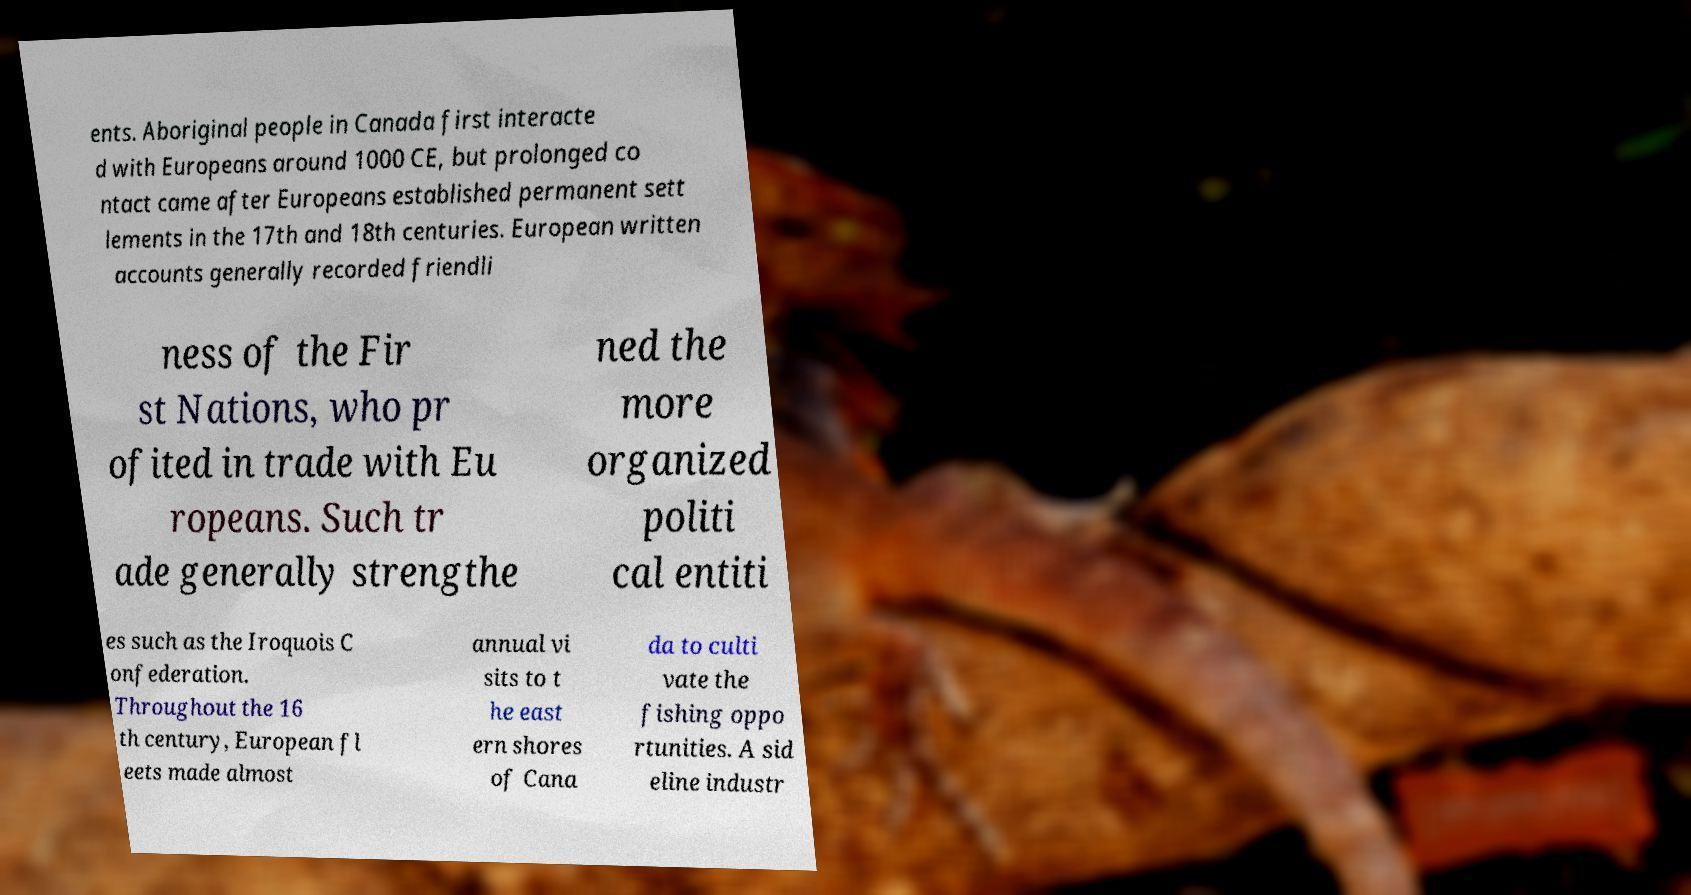For documentation purposes, I need the text within this image transcribed. Could you provide that? ents. Aboriginal people in Canada first interacte d with Europeans around 1000 CE, but prolonged co ntact came after Europeans established permanent sett lements in the 17th and 18th centuries. European written accounts generally recorded friendli ness of the Fir st Nations, who pr ofited in trade with Eu ropeans. Such tr ade generally strengthe ned the more organized politi cal entiti es such as the Iroquois C onfederation. Throughout the 16 th century, European fl eets made almost annual vi sits to t he east ern shores of Cana da to culti vate the fishing oppo rtunities. A sid eline industr 